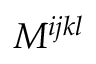Convert formula to latex. <formula><loc_0><loc_0><loc_500><loc_500>M ^ { i j k l }</formula> 